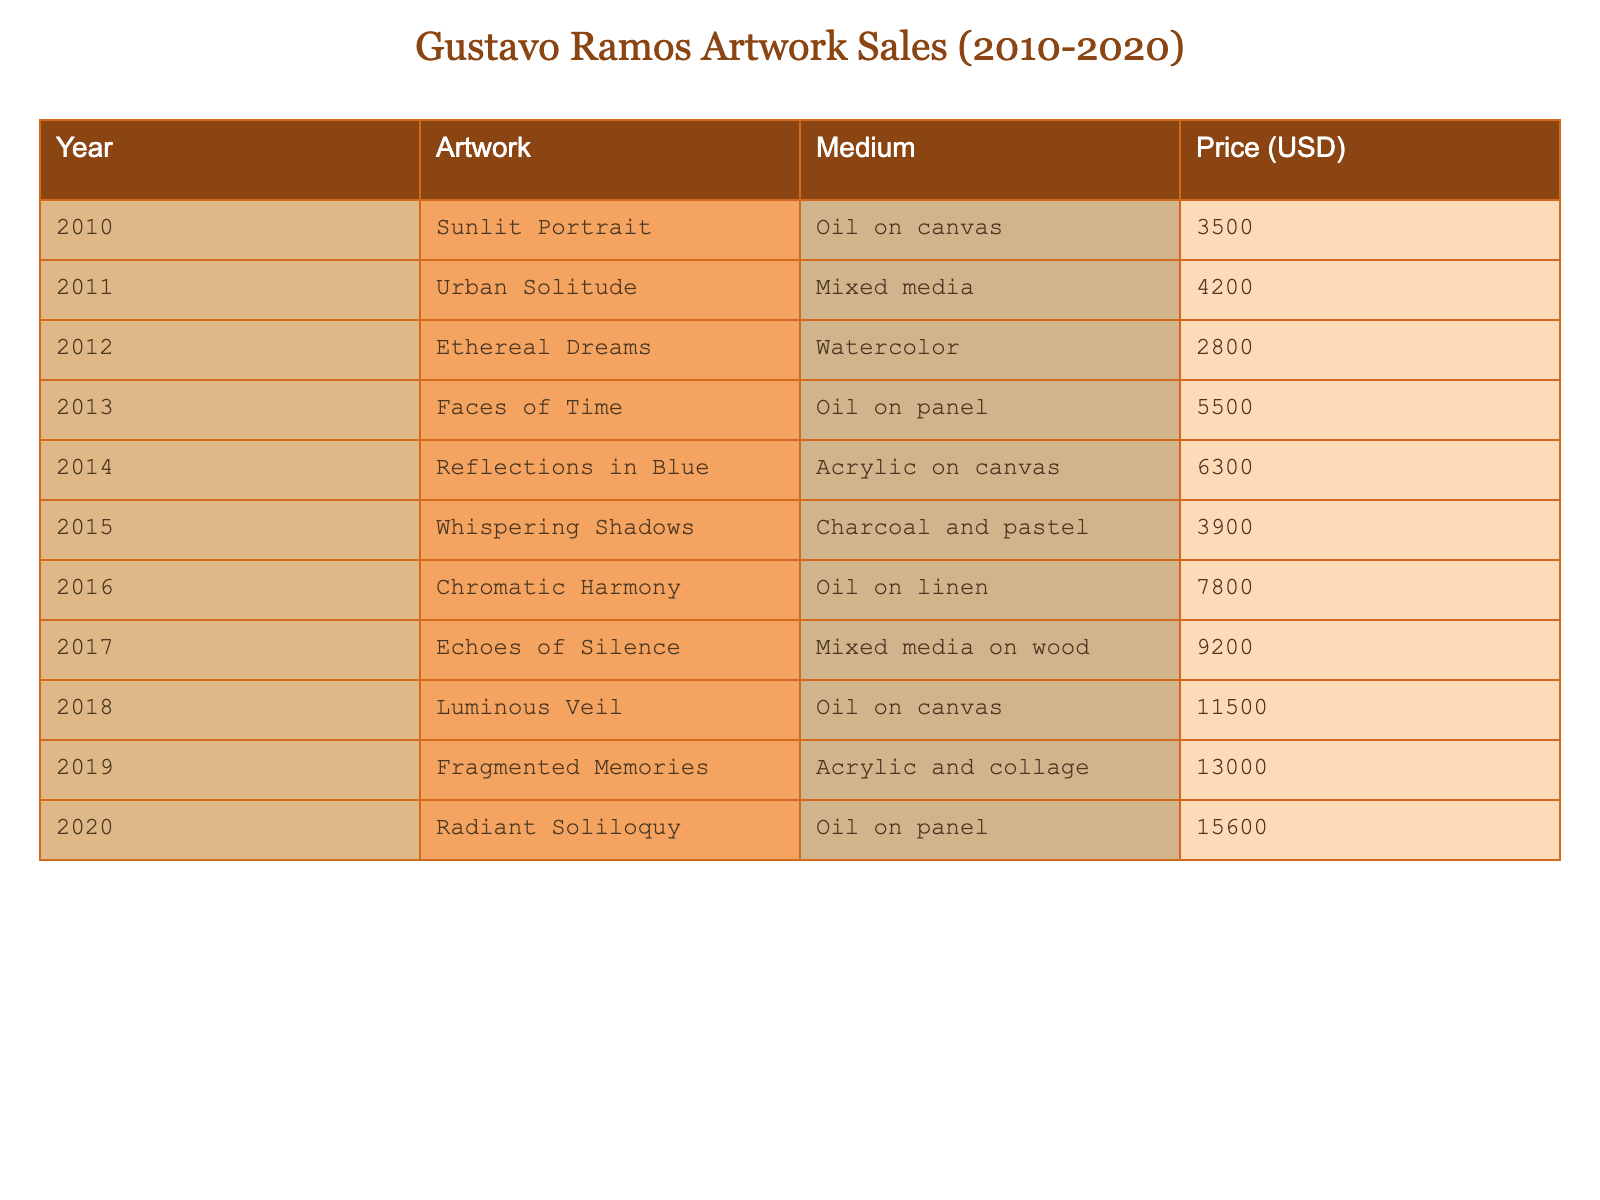What was the highest sale price among Gustavo Ramos's artworks between 2010 and 2020? By examining the price column in the table, the highest value recorded is 15600 for the artwork "Radiant Soliloquy" in 2020.
Answer: 15600 What year saw the sale of "Fragmented Memories"? The table shows the artwork "Fragmented Memories" was sold in 2019.
Answer: 2019 What is the total revenue generated by Gustavo Ramos's artwork sales from 2010 to 2020? To find the total revenue, we add the prices of all artworks: 3500 + 4200 + 2800 + 5500 + 6300 + 3900 + 7800 + 9200 + 11500 + 13000 + 15600, which equals 66500.
Answer: 66500 Which medium had the highest sale price, and what was that price? Looking at the table, "Radiant Soliloquy" in Oil on panel had the highest sale price of 15600, marking it as the highest among various mediums.
Answer: Oil on panel, 15600 What was the difference in sale price between "Ethereal Dreams" and "Whispering Shadows"? "Ethereal Dreams" sold for 2800, while "Whispering Shadows" sold for 3900. The difference is 3900 - 2800 = 1100.
Answer: 1100 Which year had the lowest sale price for an artwork, and what was the price? Checking the prices from the table, the lowest sale price is 2800 for "Ethereal Dreams" in 2012, making it the least expensive in that period.
Answer: 2012, 2800 How many artworks were sold for prices over 6000 USD? By inspecting the table, the artworks sold for more than 6000 USD are "Chromatic Harmony," "Echoes of Silence," "Luminous Veil," "Fragmented Memories," and "Radiant Soliloquy." There are 5 such artworks.
Answer: 5 What was the average sale price of Gustavo Ramos’s artworks from 2010 to 2020? To calculate the average, we first sum up all prices (66500) and then divide by the number of artworks (11), resulting in an average of 6054.55, rounded to two decimal places.
Answer: 6054.55 In which year did "Urban Solitude" sell, and what was its sale price? "Urban Solitude" was sold in 2011 for a price of 4200, as seen in the relevant row of the table.
Answer: 2011, 4200 Which two artworks had a combined sale price of 9500 USD? Checking the sale prices, "Whispering Shadows" (3900) and "Ethereal Dreams" (2800) combined equal 6700, not reaching 9500. Next, considering "Reflections in Blue" (6300) and "Ethereal Dreams" (2800) combined, they add up to 9100 — still not 9500. Thus, there are no artworks that combine to 9500 from the provided data.
Answer: None 